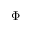<formula> <loc_0><loc_0><loc_500><loc_500>\Phi</formula> 